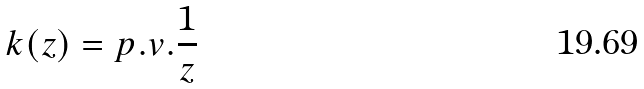Convert formula to latex. <formula><loc_0><loc_0><loc_500><loc_500>k ( z ) = p . v . \frac { 1 } { z }</formula> 